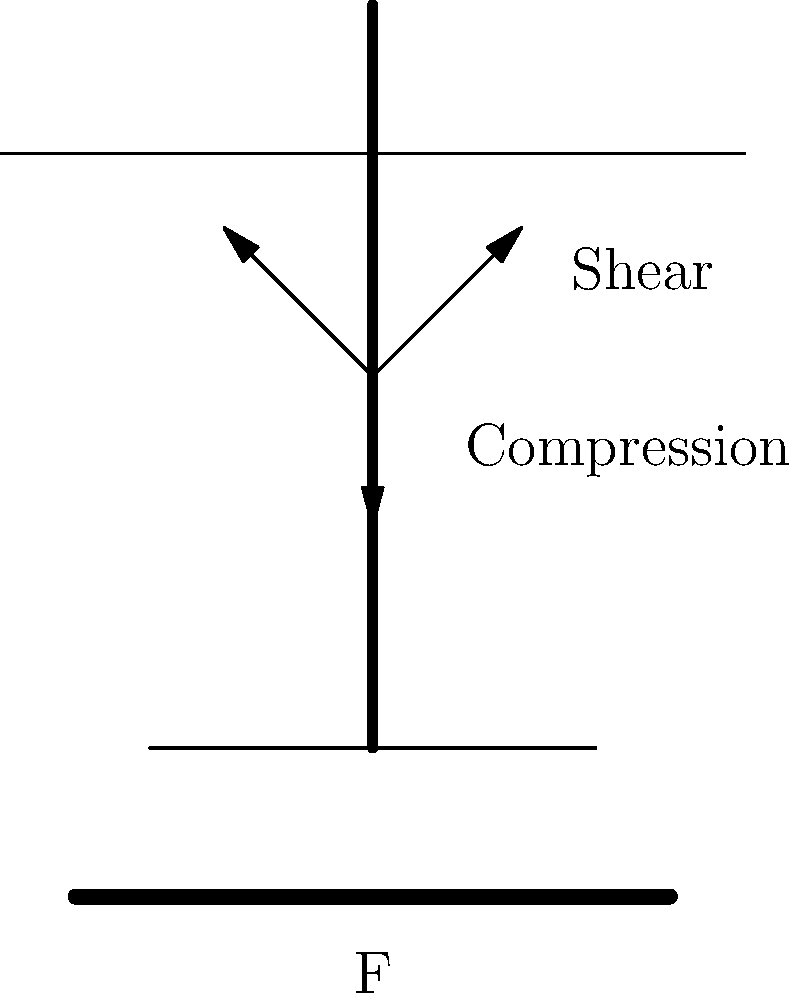In a deadlift, a weightlifter experiences compressive and shear forces on their spine. If the total weight being lifted is 200 kg and the angle of the spine relative to the vertical is 30°, what is the magnitude of the shear force acting on the L4/L5 vertebral joint? Assume that 60% of the total load is transferred through this joint. To solve this problem, we'll follow these steps:

1. Calculate the total force on the spine:
   $F_{total} = m \times g = 200 \text{ kg} \times 9.81 \text{ m/s}^2 = 1962 \text{ N}$

2. Determine the force acting on the L4/L5 joint:
   $F_{joint} = 60\% \times F_{total} = 0.6 \times 1962 \text{ N} = 1177.2 \text{ N}$

3. Resolve the force into its components:
   - Compressive force: $F_c = F_{joint} \times \cos(30°)$
   - Shear force: $F_s = F_{joint} \times \sin(30°)$

4. Calculate the shear force:
   $F_s = 1177.2 \text{ N} \times \sin(30°) = 1177.2 \text{ N} \times 0.5 = 588.6 \text{ N}$

The magnitude of the shear force acting on the L4/L5 vertebral joint is approximately 588.6 N.
Answer: 588.6 N 